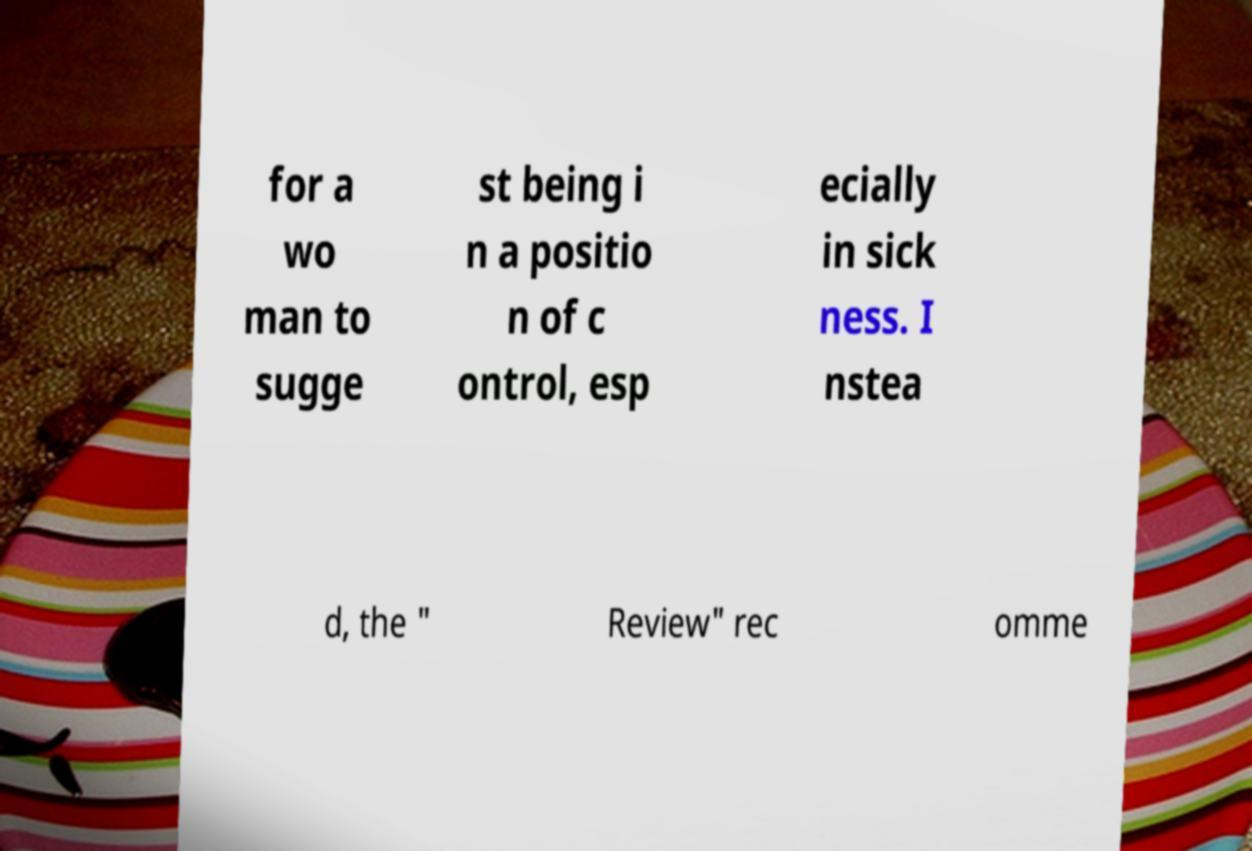Can you accurately transcribe the text from the provided image for me? for a wo man to sugge st being i n a positio n of c ontrol, esp ecially in sick ness. I nstea d, the " Review" rec omme 